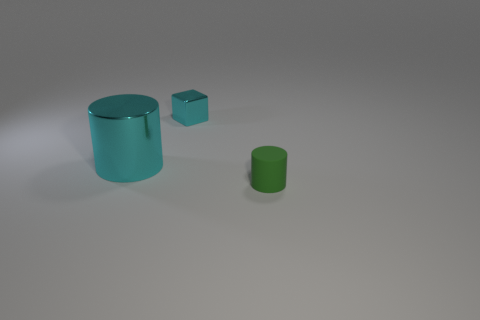Add 2 cyan metal cubes. How many objects exist? 5 Subtract all blocks. How many objects are left? 2 Subtract 0 green cubes. How many objects are left? 3 Subtract all small red metallic things. Subtract all cyan things. How many objects are left? 1 Add 3 big things. How many big things are left? 4 Add 2 big cyan metal blocks. How many big cyan metal blocks exist? 2 